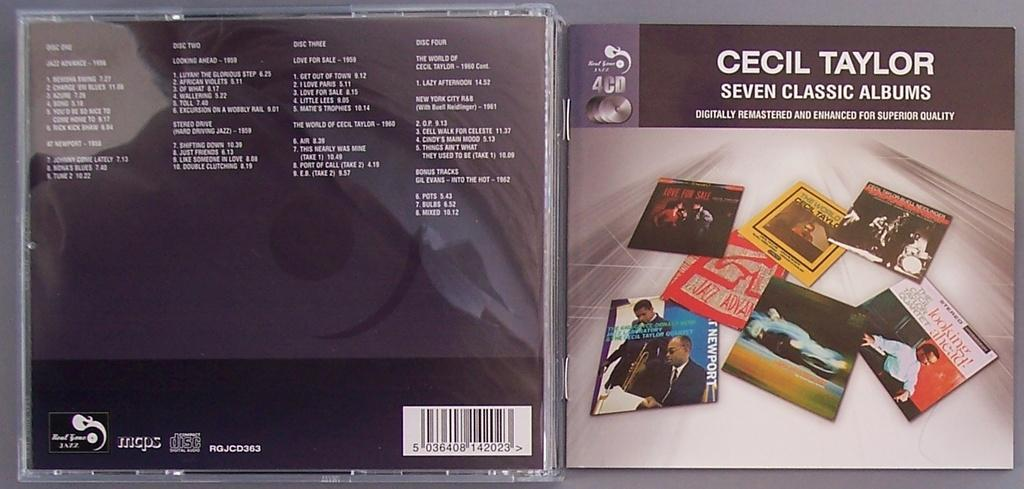<image>
Summarize the visual content of the image. A cd by Cecil Taylor is open to show the front and back covers. 